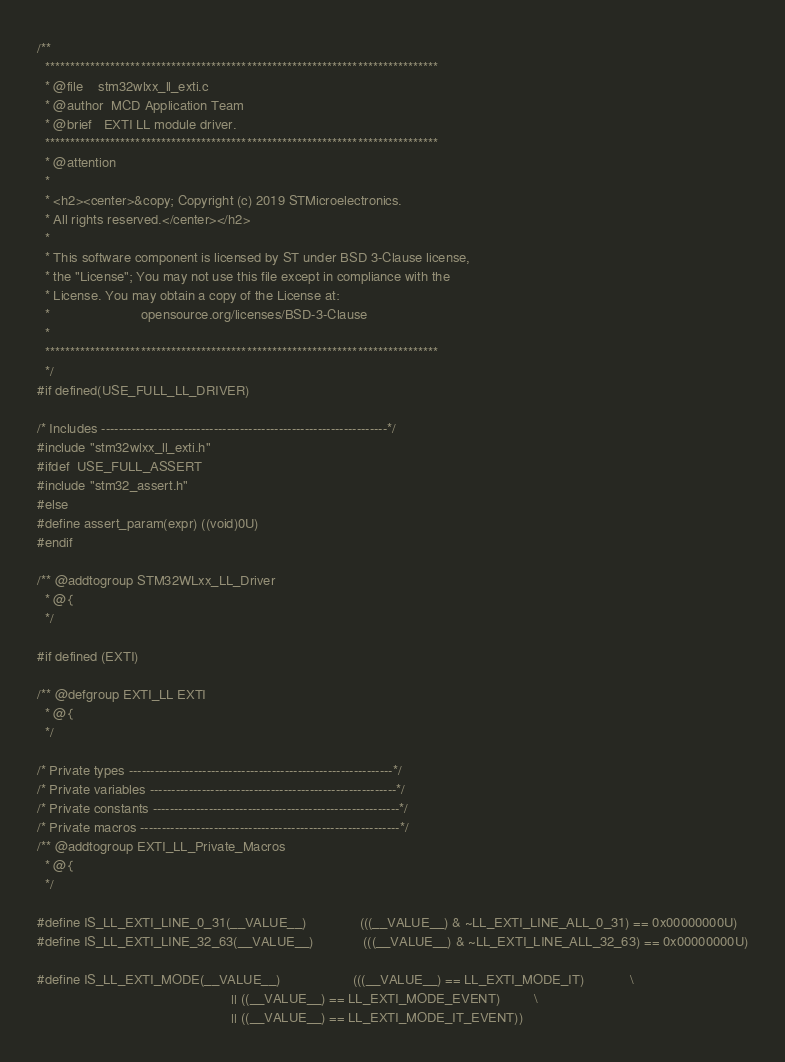<code> <loc_0><loc_0><loc_500><loc_500><_C_>/**
  ******************************************************************************
  * @file    stm32wlxx_ll_exti.c
  * @author  MCD Application Team
  * @brief   EXTI LL module driver.
  ******************************************************************************
  * @attention
  *
  * <h2><center>&copy; Copyright (c) 2019 STMicroelectronics. 
  * All rights reserved.</center></h2>
  *
  * This software component is licensed by ST under BSD 3-Clause license,
  * the "License"; You may not use this file except in compliance with the 
  * License. You may obtain a copy of the License at:
  *                        opensource.org/licenses/BSD-3-Clause
  *
  ******************************************************************************
  */
#if defined(USE_FULL_LL_DRIVER)

/* Includes ------------------------------------------------------------------*/
#include "stm32wlxx_ll_exti.h"
#ifdef  USE_FULL_ASSERT
#include "stm32_assert.h"
#else
#define assert_param(expr) ((void)0U)
#endif

/** @addtogroup STM32WLxx_LL_Driver
  * @{
  */

#if defined (EXTI)

/** @defgroup EXTI_LL EXTI
  * @{
  */

/* Private types -------------------------------------------------------------*/
/* Private variables ---------------------------------------------------------*/
/* Private constants ---------------------------------------------------------*/
/* Private macros ------------------------------------------------------------*/
/** @addtogroup EXTI_LL_Private_Macros
  * @{
  */

#define IS_LL_EXTI_LINE_0_31(__VALUE__)              (((__VALUE__) & ~LL_EXTI_LINE_ALL_0_31) == 0x00000000U)
#define IS_LL_EXTI_LINE_32_63(__VALUE__)             (((__VALUE__) & ~LL_EXTI_LINE_ALL_32_63) == 0x00000000U)

#define IS_LL_EXTI_MODE(__VALUE__)                   (((__VALUE__) == LL_EXTI_MODE_IT)            \
                                                   || ((__VALUE__) == LL_EXTI_MODE_EVENT)         \
                                                   || ((__VALUE__) == LL_EXTI_MODE_IT_EVENT))

</code> 